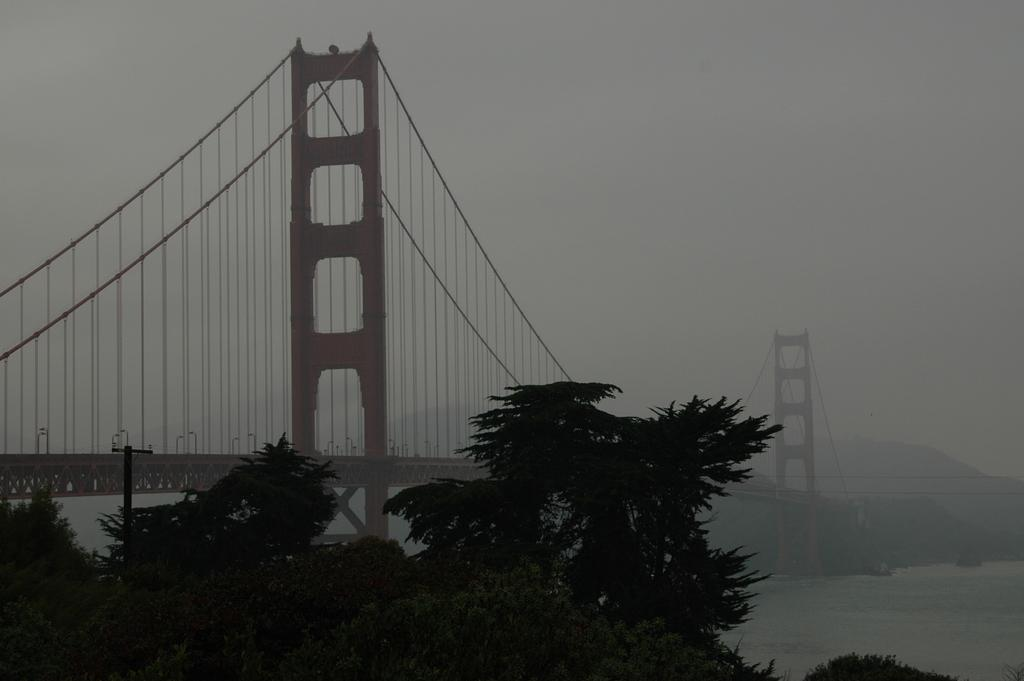What type of vegetation is visible in the front of the image? There are trees in the front of the image. What type of structure can be seen in the background of the image? There is a bridge in the background of the image. What else can be seen in the background of the image? There are wires in the background of the image. How would you describe the lighting in the image? The image appears to be slightly dark. What songs are being sung by the police officers in the image? There are no police officers or songs present in the image. What is the afterthought of the person who took the image? We cannot determine the afterthought of the person who took the image based on the information provided. 